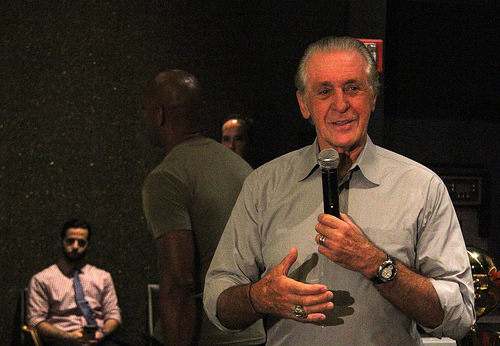<image>
Can you confirm if the black guy is in front of the white guy? No. The black guy is not in front of the white guy. The spatial positioning shows a different relationship between these objects. 